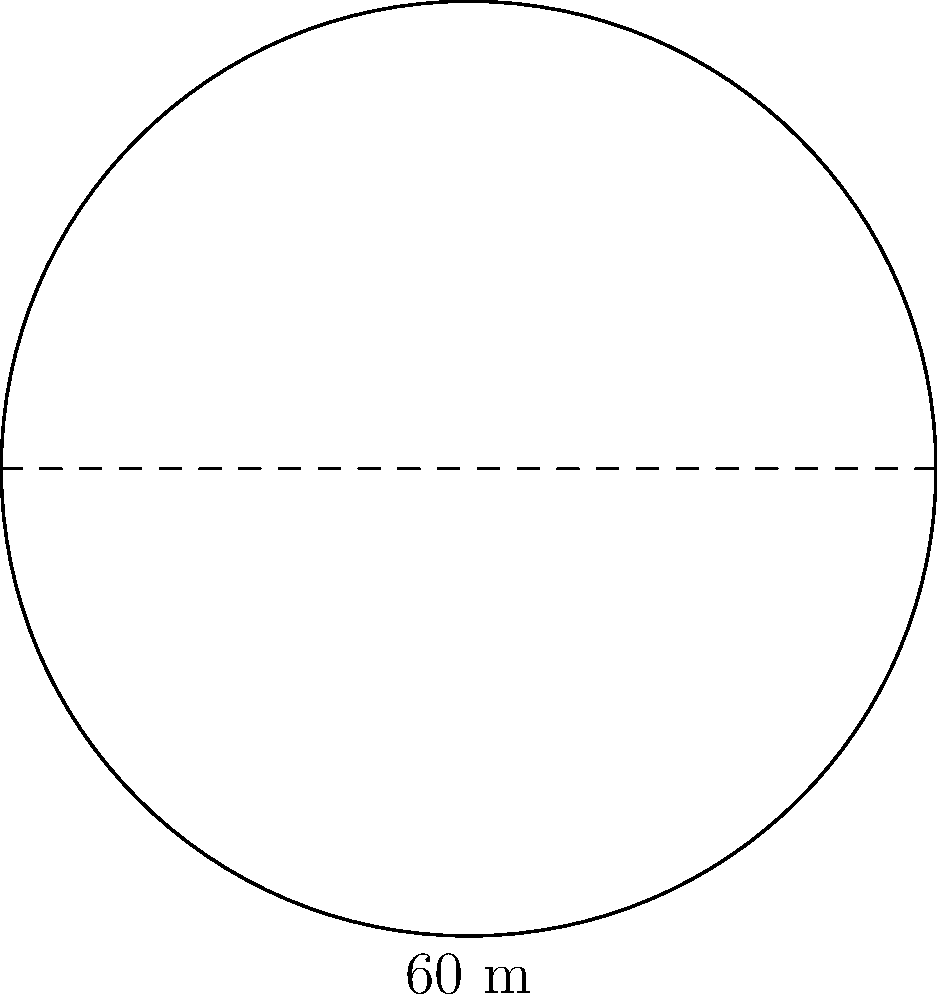As a retired crane operator, you're consulting on a circular construction site. The site has a diameter of 60 meters. What is the total area of the construction site in square meters? Round your answer to the nearest whole number. Let's approach this step-by-step:

1) We're given the diameter of the circular site, which is 60 meters.

2) To find the area, we need the radius. The radius is half the diameter:
   $r = \frac{60}{2} = 30$ meters

3) The formula for the area of a circle is $A = \pi r^2$

4) Substituting our radius:
   $A = \pi (30)^2$

5) Simplify:
   $A = \pi (900)$

6) Use 3.14159 as an approximation for $\pi$:
   $A = 3.14159 \times 900 = 2827.431$ square meters

7) Rounding to the nearest whole number:
   $A \approx 2827$ square meters
Answer: 2827 square meters 